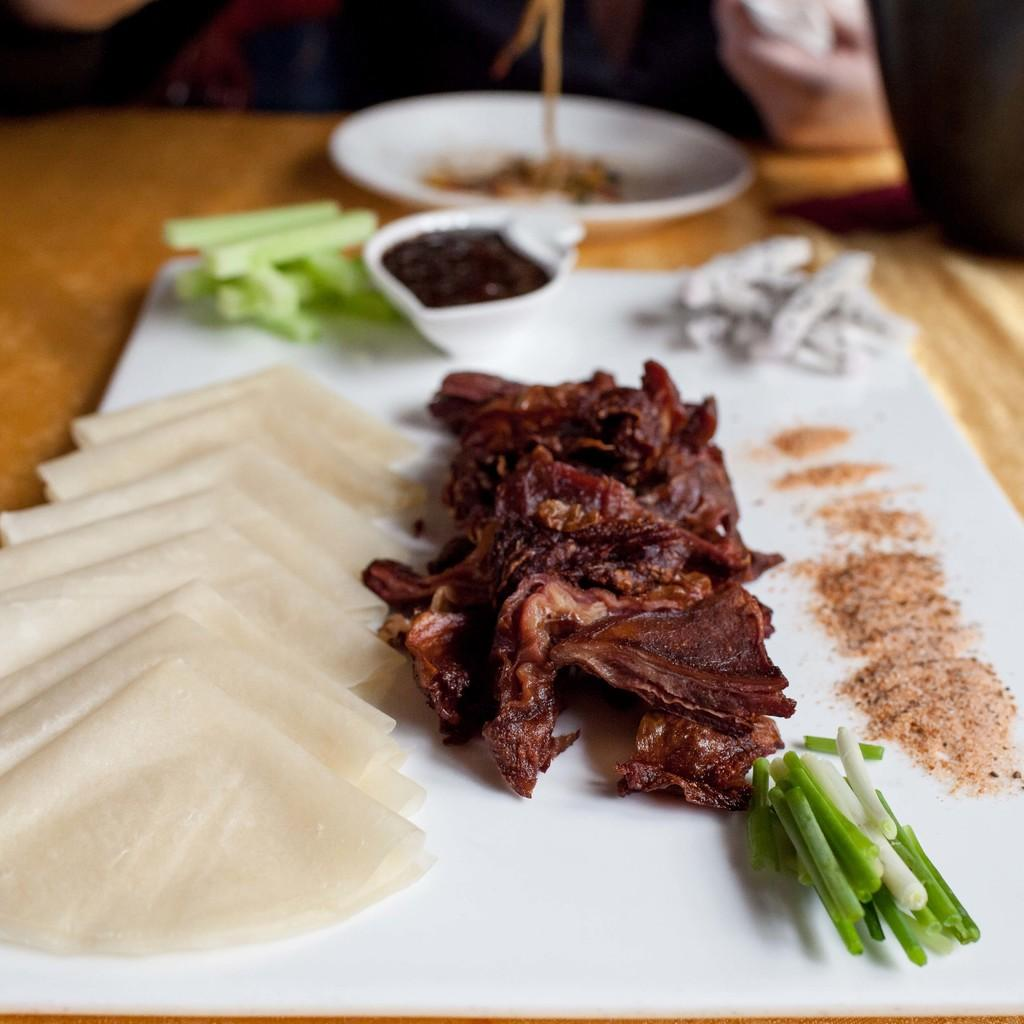What is on the plate that is visible in the image? There is a plate of food in the image. What other dish can be seen in the image besides the plate of food? There is another bowl in the image. Can you describe the person in the image? There is a person sitting in the image. What type of stew is the person eating in the image? There is no stew present in the image; it only shows a plate of food and another bowl. How many bites has the person taken out of the food in the image? The image does not show any indication of how much the person has eaten, so it cannot be determined. 